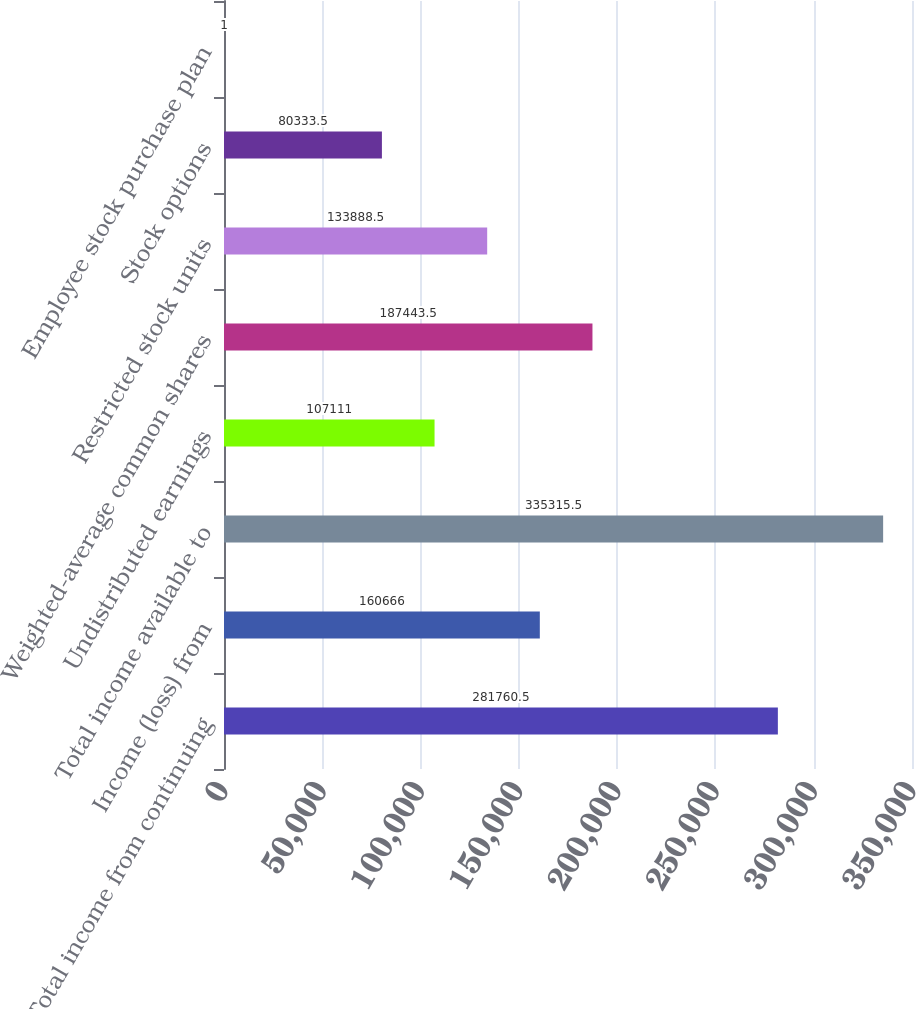Convert chart to OTSL. <chart><loc_0><loc_0><loc_500><loc_500><bar_chart><fcel>Total income from continuing<fcel>Income (loss) from<fcel>Total income available to<fcel>Undistributed earnings<fcel>Weighted-average common shares<fcel>Restricted stock units<fcel>Stock options<fcel>Employee stock purchase plan<nl><fcel>281760<fcel>160666<fcel>335316<fcel>107111<fcel>187444<fcel>133888<fcel>80333.5<fcel>1<nl></chart> 